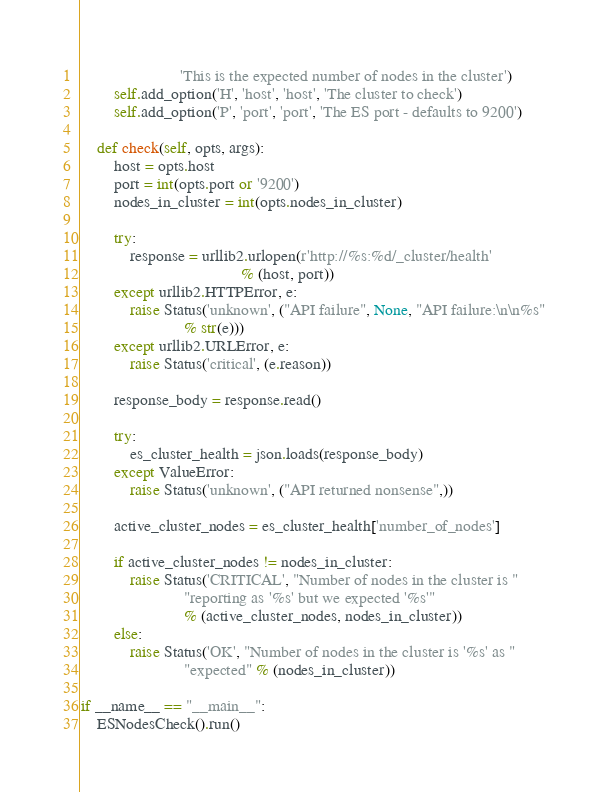Convert code to text. <code><loc_0><loc_0><loc_500><loc_500><_Python_>                        'This is the expected number of nodes in the cluster')
        self.add_option('H', 'host', 'host', 'The cluster to check')
        self.add_option('P', 'port', 'port', 'The ES port - defaults to 9200')

    def check(self, opts, args):
        host = opts.host
        port = int(opts.port or '9200')
        nodes_in_cluster = int(opts.nodes_in_cluster)

        try:
            response = urllib2.urlopen(r'http://%s:%d/_cluster/health'
                                       % (host, port))
        except urllib2.HTTPError, e:
            raise Status('unknown', ("API failure", None, "API failure:\n\n%s"
                         % str(e)))
        except urllib2.URLError, e:
            raise Status('critical', (e.reason))

        response_body = response.read()

        try:
            es_cluster_health = json.loads(response_body)
        except ValueError:
            raise Status('unknown', ("API returned nonsense",))

        active_cluster_nodes = es_cluster_health['number_of_nodes']

        if active_cluster_nodes != nodes_in_cluster:
            raise Status('CRITICAL', "Number of nodes in the cluster is "
                         "reporting as '%s' but we expected '%s'"
                         % (active_cluster_nodes, nodes_in_cluster))
        else:
            raise Status('OK', "Number of nodes in the cluster is '%s' as "
                         "expected" % (nodes_in_cluster))

if __name__ == "__main__":
    ESNodesCheck().run()
</code> 